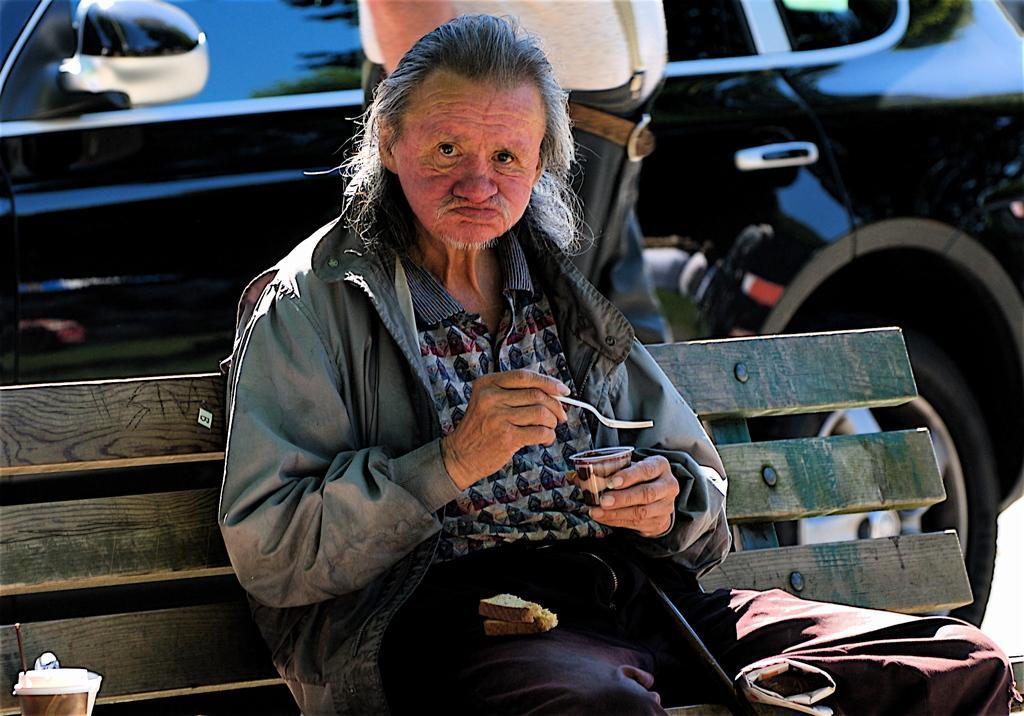Can you describe this image briefly? In this picture, we see an old man is sitting on the wooden bench. He is holding a cup and a spoon in his hands. We see a cup and a brown cloth on the bench. Behind him, we see a man is standing. In the background, we see a black car. 